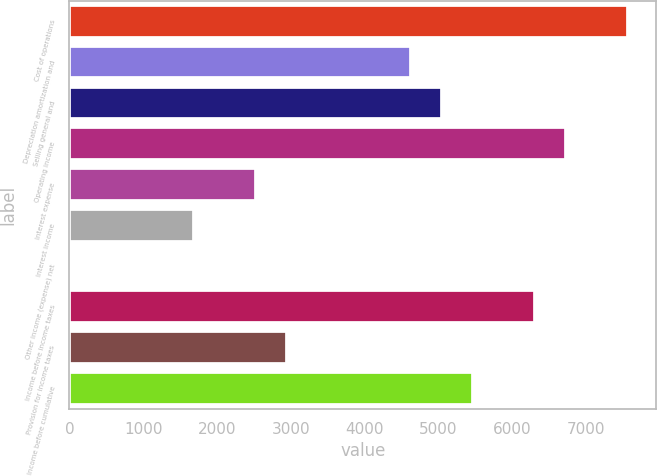<chart> <loc_0><loc_0><loc_500><loc_500><bar_chart><fcel>Cost of operations<fcel>Depreciation amortization and<fcel>Selling general and<fcel>Operating income<fcel>Interest expense<fcel>Interest income<fcel>Other income (expense) net<fcel>Income before income taxes<fcel>Provision for income taxes<fcel>Income before cumulative<nl><fcel>7576.14<fcel>4629.98<fcel>5050.86<fcel>6734.38<fcel>2525.58<fcel>1683.82<fcel>0.3<fcel>6313.5<fcel>2946.46<fcel>5471.74<nl></chart> 